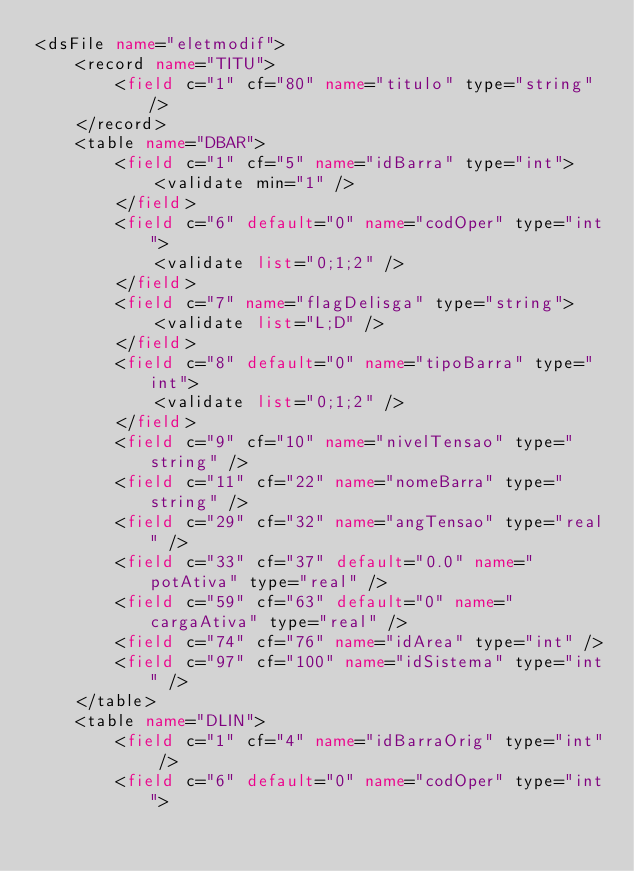<code> <loc_0><loc_0><loc_500><loc_500><_XML_><dsFile name="eletmodif">
	<record name="TITU">
		<field c="1" cf="80" name="titulo" type="string" />
	</record>
	<table name="DBAR">
		<field c="1" cf="5" name="idBarra" type="int">
			<validate min="1" />
		</field>
		<field c="6" default="0" name="codOper" type="int">
			<validate list="0;1;2" />
		</field>
		<field c="7" name="flagDelisga" type="string">
			<validate list="L;D" />
		</field>
		<field c="8" default="0" name="tipoBarra" type="int">
			<validate list="0;1;2" />
		</field>
		<field c="9" cf="10" name="nivelTensao" type="string" />
		<field c="11" cf="22" name="nomeBarra" type="string" />
		<field c="29" cf="32" name="angTensao" type="real" />
		<field c="33" cf="37" default="0.0" name="potAtiva" type="real" />
		<field c="59" cf="63" default="0" name="cargaAtiva" type="real" />
		<field c="74" cf="76" name="idArea" type="int" />
		<field c="97" cf="100" name="idSistema" type="int" />
	</table>
	<table name="DLIN">
		<field c="1" cf="4" name="idBarraOrig" type="int" />
		<field c="6" default="0" name="codOper" type="int"></code> 